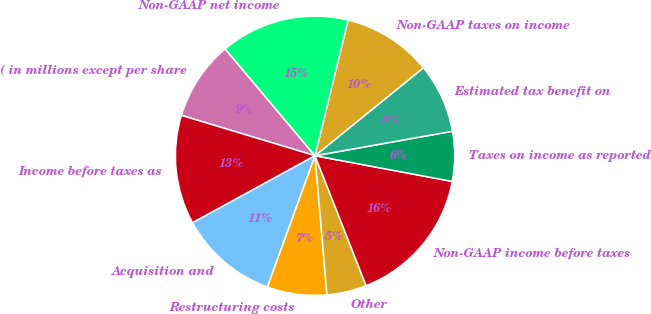Convert chart. <chart><loc_0><loc_0><loc_500><loc_500><pie_chart><fcel>( in millions except per share<fcel>Income before taxes as<fcel>Acquisition and<fcel>Restructuring costs<fcel>Other<fcel>Non-GAAP income before taxes<fcel>Taxes on income as reported<fcel>Estimated tax benefit on<fcel>Non-GAAP taxes on income<fcel>Non-GAAP net income<nl><fcel>9.2%<fcel>12.64%<fcel>11.49%<fcel>6.9%<fcel>4.6%<fcel>16.09%<fcel>5.75%<fcel>8.05%<fcel>10.34%<fcel>14.94%<nl></chart> 